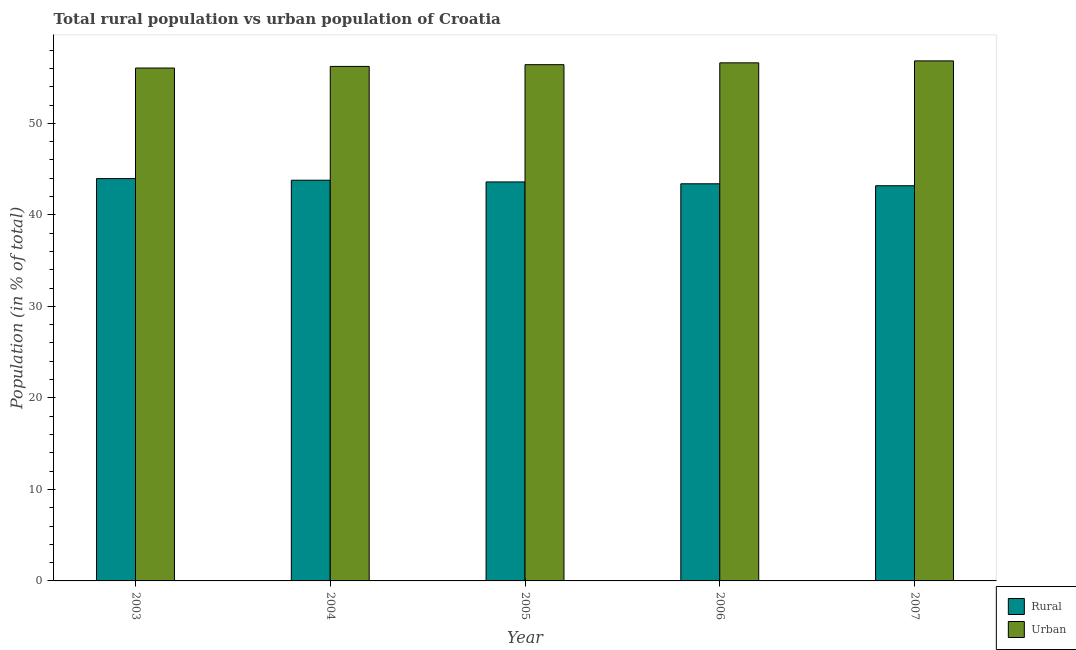How many different coloured bars are there?
Give a very brief answer. 2. Are the number of bars per tick equal to the number of legend labels?
Offer a very short reply. Yes. Are the number of bars on each tick of the X-axis equal?
Provide a short and direct response. Yes. How many bars are there on the 2nd tick from the left?
Ensure brevity in your answer.  2. What is the label of the 3rd group of bars from the left?
Your answer should be compact. 2005. In how many cases, is the number of bars for a given year not equal to the number of legend labels?
Your response must be concise. 0. What is the urban population in 2007?
Keep it short and to the point. 56.82. Across all years, what is the maximum urban population?
Your answer should be compact. 56.82. Across all years, what is the minimum rural population?
Ensure brevity in your answer.  43.18. In which year was the rural population maximum?
Your response must be concise. 2003. What is the total urban population in the graph?
Make the answer very short. 282.09. What is the difference between the urban population in 2003 and that in 2005?
Your answer should be compact. -0.37. What is the difference between the urban population in 2003 and the rural population in 2005?
Ensure brevity in your answer.  -0.37. What is the average urban population per year?
Offer a terse response. 56.42. In the year 2007, what is the difference between the rural population and urban population?
Your answer should be compact. 0. What is the ratio of the urban population in 2003 to that in 2006?
Keep it short and to the point. 0.99. Is the difference between the urban population in 2005 and 2007 greater than the difference between the rural population in 2005 and 2007?
Your answer should be very brief. No. What is the difference between the highest and the second highest urban population?
Make the answer very short. 0.21. What is the difference between the highest and the lowest urban population?
Your answer should be compact. 0.78. In how many years, is the rural population greater than the average rural population taken over all years?
Your answer should be very brief. 3. What does the 1st bar from the left in 2006 represents?
Make the answer very short. Rural. What does the 2nd bar from the right in 2005 represents?
Your answer should be very brief. Rural. What is the difference between two consecutive major ticks on the Y-axis?
Offer a terse response. 10. Does the graph contain grids?
Give a very brief answer. No. Where does the legend appear in the graph?
Offer a very short reply. Bottom right. What is the title of the graph?
Offer a terse response. Total rural population vs urban population of Croatia. Does "Adolescent fertility rate" appear as one of the legend labels in the graph?
Give a very brief answer. No. What is the label or title of the X-axis?
Your response must be concise. Year. What is the label or title of the Y-axis?
Give a very brief answer. Population (in % of total). What is the Population (in % of total) of Rural in 2003?
Keep it short and to the point. 43.96. What is the Population (in % of total) of Urban in 2003?
Provide a short and direct response. 56.04. What is the Population (in % of total) in Rural in 2004?
Offer a very short reply. 43.78. What is the Population (in % of total) of Urban in 2004?
Your response must be concise. 56.22. What is the Population (in % of total) in Rural in 2005?
Give a very brief answer. 43.59. What is the Population (in % of total) in Urban in 2005?
Your answer should be very brief. 56.41. What is the Population (in % of total) of Rural in 2006?
Keep it short and to the point. 43.39. What is the Population (in % of total) of Urban in 2006?
Ensure brevity in your answer.  56.61. What is the Population (in % of total) of Rural in 2007?
Ensure brevity in your answer.  43.18. What is the Population (in % of total) in Urban in 2007?
Ensure brevity in your answer.  56.82. Across all years, what is the maximum Population (in % of total) in Rural?
Ensure brevity in your answer.  43.96. Across all years, what is the maximum Population (in % of total) of Urban?
Provide a short and direct response. 56.82. Across all years, what is the minimum Population (in % of total) of Rural?
Provide a short and direct response. 43.18. Across all years, what is the minimum Population (in % of total) in Urban?
Make the answer very short. 56.04. What is the total Population (in % of total) in Rural in the graph?
Your response must be concise. 217.91. What is the total Population (in % of total) in Urban in the graph?
Your answer should be compact. 282.09. What is the difference between the Population (in % of total) in Rural in 2003 and that in 2004?
Provide a succinct answer. 0.18. What is the difference between the Population (in % of total) in Urban in 2003 and that in 2004?
Offer a very short reply. -0.18. What is the difference between the Population (in % of total) of Rural in 2003 and that in 2005?
Your response must be concise. 0.37. What is the difference between the Population (in % of total) of Urban in 2003 and that in 2005?
Provide a succinct answer. -0.37. What is the difference between the Population (in % of total) in Rural in 2003 and that in 2006?
Ensure brevity in your answer.  0.57. What is the difference between the Population (in % of total) of Urban in 2003 and that in 2006?
Provide a short and direct response. -0.57. What is the difference between the Population (in % of total) of Rural in 2003 and that in 2007?
Offer a very short reply. 0.78. What is the difference between the Population (in % of total) of Urban in 2003 and that in 2007?
Provide a short and direct response. -0.78. What is the difference between the Population (in % of total) in Rural in 2004 and that in 2005?
Ensure brevity in your answer.  0.19. What is the difference between the Population (in % of total) in Urban in 2004 and that in 2005?
Your answer should be very brief. -0.19. What is the difference between the Population (in % of total) in Rural in 2004 and that in 2006?
Ensure brevity in your answer.  0.39. What is the difference between the Population (in % of total) in Urban in 2004 and that in 2006?
Your response must be concise. -0.39. What is the difference between the Population (in % of total) of Rural in 2004 and that in 2007?
Provide a short and direct response. 0.6. What is the difference between the Population (in % of total) of Urban in 2004 and that in 2007?
Ensure brevity in your answer.  -0.6. What is the difference between the Population (in % of total) in Rural in 2005 and that in 2006?
Offer a very short reply. 0.2. What is the difference between the Population (in % of total) of Urban in 2005 and that in 2006?
Give a very brief answer. -0.2. What is the difference between the Population (in % of total) in Rural in 2005 and that in 2007?
Your answer should be very brief. 0.42. What is the difference between the Population (in % of total) in Urban in 2005 and that in 2007?
Your answer should be compact. -0.42. What is the difference between the Population (in % of total) of Rural in 2006 and that in 2007?
Keep it short and to the point. 0.21. What is the difference between the Population (in % of total) in Urban in 2006 and that in 2007?
Ensure brevity in your answer.  -0.21. What is the difference between the Population (in % of total) in Rural in 2003 and the Population (in % of total) in Urban in 2004?
Your response must be concise. -12.26. What is the difference between the Population (in % of total) of Rural in 2003 and the Population (in % of total) of Urban in 2005?
Ensure brevity in your answer.  -12.45. What is the difference between the Population (in % of total) of Rural in 2003 and the Population (in % of total) of Urban in 2006?
Make the answer very short. -12.65. What is the difference between the Population (in % of total) of Rural in 2003 and the Population (in % of total) of Urban in 2007?
Provide a short and direct response. -12.86. What is the difference between the Population (in % of total) in Rural in 2004 and the Population (in % of total) in Urban in 2005?
Give a very brief answer. -12.62. What is the difference between the Population (in % of total) in Rural in 2004 and the Population (in % of total) in Urban in 2006?
Ensure brevity in your answer.  -12.82. What is the difference between the Population (in % of total) in Rural in 2004 and the Population (in % of total) in Urban in 2007?
Your answer should be compact. -13.04. What is the difference between the Population (in % of total) in Rural in 2005 and the Population (in % of total) in Urban in 2006?
Make the answer very short. -13.01. What is the difference between the Population (in % of total) of Rural in 2005 and the Population (in % of total) of Urban in 2007?
Ensure brevity in your answer.  -13.23. What is the difference between the Population (in % of total) of Rural in 2006 and the Population (in % of total) of Urban in 2007?
Offer a very short reply. -13.43. What is the average Population (in % of total) in Rural per year?
Ensure brevity in your answer.  43.58. What is the average Population (in % of total) of Urban per year?
Make the answer very short. 56.42. In the year 2003, what is the difference between the Population (in % of total) of Rural and Population (in % of total) of Urban?
Give a very brief answer. -12.08. In the year 2004, what is the difference between the Population (in % of total) of Rural and Population (in % of total) of Urban?
Provide a short and direct response. -12.43. In the year 2005, what is the difference between the Population (in % of total) of Rural and Population (in % of total) of Urban?
Ensure brevity in your answer.  -12.81. In the year 2006, what is the difference between the Population (in % of total) of Rural and Population (in % of total) of Urban?
Give a very brief answer. -13.22. In the year 2007, what is the difference between the Population (in % of total) in Rural and Population (in % of total) in Urban?
Keep it short and to the point. -13.64. What is the ratio of the Population (in % of total) of Rural in 2003 to that in 2004?
Make the answer very short. 1. What is the ratio of the Population (in % of total) in Rural in 2003 to that in 2005?
Offer a terse response. 1.01. What is the ratio of the Population (in % of total) in Urban in 2003 to that in 2005?
Provide a succinct answer. 0.99. What is the ratio of the Population (in % of total) of Rural in 2003 to that in 2006?
Offer a very short reply. 1.01. What is the ratio of the Population (in % of total) of Urban in 2003 to that in 2006?
Provide a short and direct response. 0.99. What is the ratio of the Population (in % of total) of Rural in 2003 to that in 2007?
Provide a short and direct response. 1.02. What is the ratio of the Population (in % of total) in Urban in 2003 to that in 2007?
Provide a succinct answer. 0.99. What is the ratio of the Population (in % of total) of Urban in 2004 to that in 2005?
Your response must be concise. 1. What is the ratio of the Population (in % of total) of Urban in 2004 to that in 2006?
Provide a short and direct response. 0.99. What is the ratio of the Population (in % of total) in Rural in 2005 to that in 2006?
Make the answer very short. 1. What is the ratio of the Population (in % of total) of Urban in 2005 to that in 2006?
Provide a short and direct response. 1. What is the ratio of the Population (in % of total) of Rural in 2005 to that in 2007?
Provide a short and direct response. 1.01. What is the ratio of the Population (in % of total) in Urban in 2005 to that in 2007?
Offer a very short reply. 0.99. What is the difference between the highest and the second highest Population (in % of total) of Rural?
Offer a very short reply. 0.18. What is the difference between the highest and the second highest Population (in % of total) of Urban?
Keep it short and to the point. 0.21. What is the difference between the highest and the lowest Population (in % of total) in Rural?
Give a very brief answer. 0.78. What is the difference between the highest and the lowest Population (in % of total) in Urban?
Offer a terse response. 0.78. 